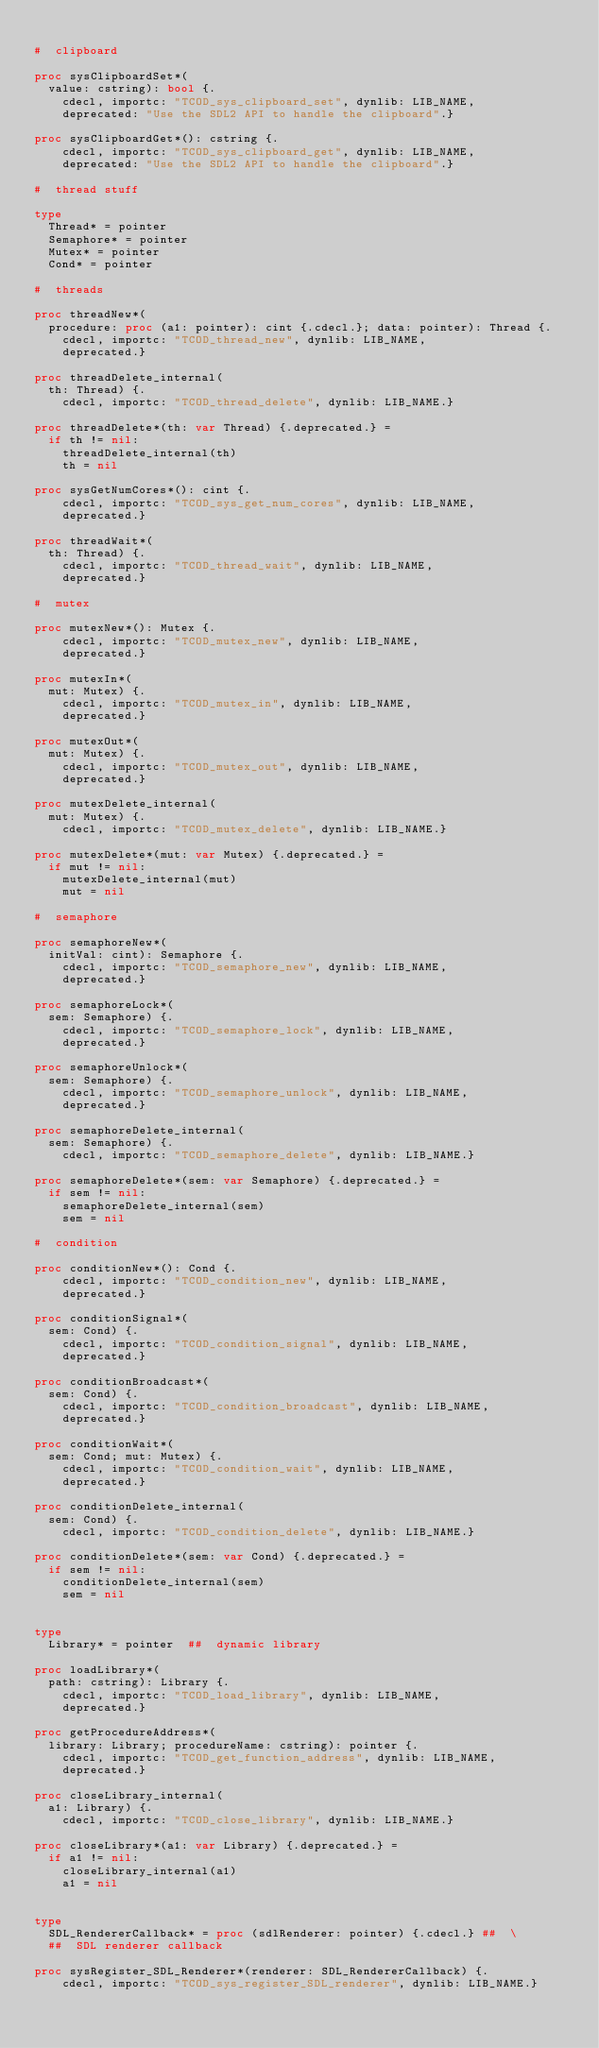Convert code to text. <code><loc_0><loc_0><loc_500><loc_500><_Nim_>
#  clipboard

proc sysClipboardSet*(
  value: cstring): bool {.
    cdecl, importc: "TCOD_sys_clipboard_set", dynlib: LIB_NAME,
    deprecated: "Use the SDL2 API to handle the clipboard".}

proc sysClipboardGet*(): cstring {.
    cdecl, importc: "TCOD_sys_clipboard_get", dynlib: LIB_NAME,
    deprecated: "Use the SDL2 API to handle the clipboard".}

#  thread stuff

type
  Thread* = pointer
  Semaphore* = pointer
  Mutex* = pointer
  Cond* = pointer

#  threads

proc threadNew*(
  procedure: proc (a1: pointer): cint {.cdecl.}; data: pointer): Thread {.
    cdecl, importc: "TCOD_thread_new", dynlib: LIB_NAME,
    deprecated.}

proc threadDelete_internal(
  th: Thread) {.
    cdecl, importc: "TCOD_thread_delete", dynlib: LIB_NAME.}

proc threadDelete*(th: var Thread) {.deprecated.} =
  if th != nil:
    threadDelete_internal(th)
    th = nil

proc sysGetNumCores*(): cint {.
    cdecl, importc: "TCOD_sys_get_num_cores", dynlib: LIB_NAME,
    deprecated.}

proc threadWait*(
  th: Thread) {.
    cdecl, importc: "TCOD_thread_wait", dynlib: LIB_NAME,
    deprecated.}

#  mutex

proc mutexNew*(): Mutex {.
    cdecl, importc: "TCOD_mutex_new", dynlib: LIB_NAME,
    deprecated.}

proc mutexIn*(
  mut: Mutex) {.
    cdecl, importc: "TCOD_mutex_in", dynlib: LIB_NAME,
    deprecated.}

proc mutexOut*(
  mut: Mutex) {.
    cdecl, importc: "TCOD_mutex_out", dynlib: LIB_NAME,
    deprecated.}

proc mutexDelete_internal(
  mut: Mutex) {.
    cdecl, importc: "TCOD_mutex_delete", dynlib: LIB_NAME.}

proc mutexDelete*(mut: var Mutex) {.deprecated.} =
  if mut != nil:
    mutexDelete_internal(mut)
    mut = nil

#  semaphore

proc semaphoreNew*(
  initVal: cint): Semaphore {.
    cdecl, importc: "TCOD_semaphore_new", dynlib: LIB_NAME,
    deprecated.}

proc semaphoreLock*(
  sem: Semaphore) {.
    cdecl, importc: "TCOD_semaphore_lock", dynlib: LIB_NAME,
    deprecated.}

proc semaphoreUnlock*(
  sem: Semaphore) {.
    cdecl, importc: "TCOD_semaphore_unlock", dynlib: LIB_NAME,
    deprecated.}

proc semaphoreDelete_internal(
  sem: Semaphore) {.
    cdecl, importc: "TCOD_semaphore_delete", dynlib: LIB_NAME.}

proc semaphoreDelete*(sem: var Semaphore) {.deprecated.} =
  if sem != nil:
    semaphoreDelete_internal(sem)
    sem = nil

#  condition

proc conditionNew*(): Cond {.
    cdecl, importc: "TCOD_condition_new", dynlib: LIB_NAME,
    deprecated.}

proc conditionSignal*(
  sem: Cond) {.
    cdecl, importc: "TCOD_condition_signal", dynlib: LIB_NAME,
    deprecated.}

proc conditionBroadcast*(
  sem: Cond) {.
    cdecl, importc: "TCOD_condition_broadcast", dynlib: LIB_NAME,
    deprecated.}

proc conditionWait*(
  sem: Cond; mut: Mutex) {.
    cdecl, importc: "TCOD_condition_wait", dynlib: LIB_NAME,
    deprecated.}

proc conditionDelete_internal(
  sem: Cond) {.
    cdecl, importc: "TCOD_condition_delete", dynlib: LIB_NAME.}

proc conditionDelete*(sem: var Cond) {.deprecated.} =
  if sem != nil:
    conditionDelete_internal(sem)
    sem = nil


type
  Library* = pointer  ##  dynamic library

proc loadLibrary*(
  path: cstring): Library {.
    cdecl, importc: "TCOD_load_library", dynlib: LIB_NAME,
    deprecated.}

proc getProcedureAddress*(
  library: Library; procedureName: cstring): pointer {.
    cdecl, importc: "TCOD_get_function_address", dynlib: LIB_NAME,
    deprecated.}

proc closeLibrary_internal(
  a1: Library) {.
    cdecl, importc: "TCOD_close_library", dynlib: LIB_NAME.}

proc closeLibrary*(a1: var Library) {.deprecated.} =
  if a1 != nil:
    closeLibrary_internal(a1)
    a1 = nil


type
  SDL_RendererCallback* = proc (sdlRenderer: pointer) {.cdecl.} ##  \
  ##  SDL renderer callback

proc sysRegister_SDL_Renderer*(renderer: SDL_RendererCallback) {.
    cdecl, importc: "TCOD_sys_register_SDL_renderer", dynlib: LIB_NAME.}

</code> 